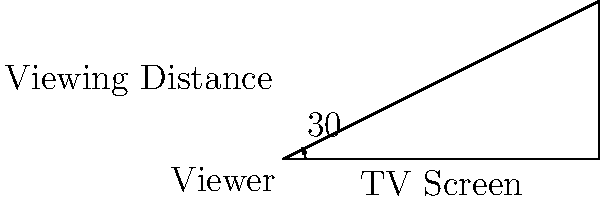As a film studies student interested in the evolution of television networks, you're researching optimal viewing distances for different TV screen sizes. If the recommended viewing angle is 30°, calculate the ideal viewing distance for a 55-inch TV (measured diagonally). Assume the TV has a 16:9 aspect ratio. Express your answer in feet, rounded to the nearest tenth. Let's approach this step-by-step:

1) First, we need to find the width of the TV screen. Given a 16:9 aspect ratio:
   - Let x be the width and 9x/16 be the height
   - Using the Pythagorean theorem: $x^2 + (9x/16)^2 = 55^2$
   - Solving this: $x ≈ 47.94$ inches (width)

2) Now, we can use the tangent function to find the viewing distance:
   - In our triangle, tan(15°) = (half of screen width) / (viewing distance)
   - $\tan(15°) = (47.94/2) / d$, where d is the viewing distance

3) Solving for d:
   $d = (47.94/2) / \tan(15°)$

4) Calculate:
   $d ≈ 89.91$ inches

5) Convert to feet:
   $89.91 \text{ inches} \times (1 \text{ foot} / 12 \text{ inches}) ≈ 7.5$ feet

Therefore, the ideal viewing distance is approximately 7.5 feet.
Answer: 7.5 feet 